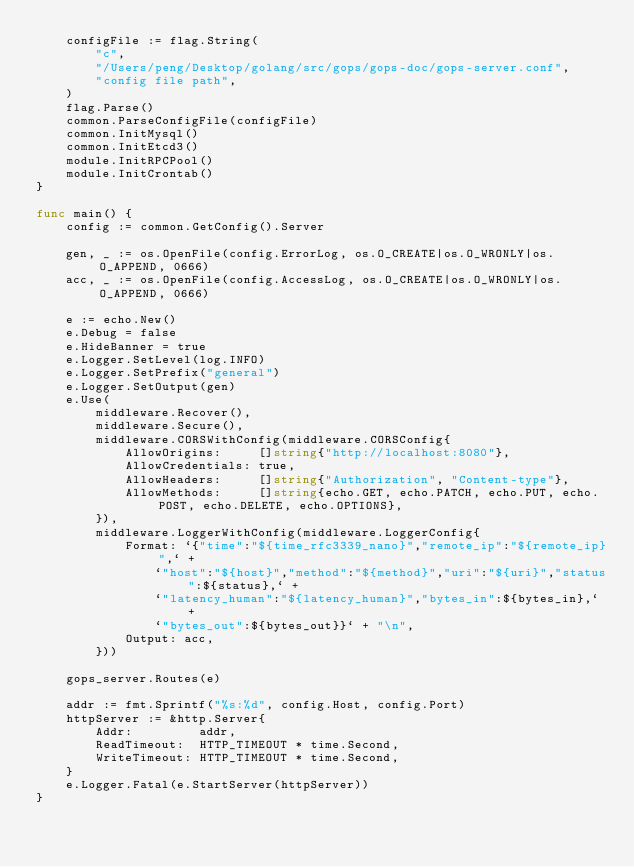<code> <loc_0><loc_0><loc_500><loc_500><_Go_>	configFile := flag.String(
		"c",
		"/Users/peng/Desktop/golang/src/gops/gops-doc/gops-server.conf",
		"config file path",
	)
	flag.Parse()
	common.ParseConfigFile(configFile)
	common.InitMysql()
	common.InitEtcd3()
	module.InitRPCPool()
	module.InitCrontab()
}

func main() {
	config := common.GetConfig().Server

	gen, _ := os.OpenFile(config.ErrorLog, os.O_CREATE|os.O_WRONLY|os.O_APPEND, 0666)
	acc, _ := os.OpenFile(config.AccessLog, os.O_CREATE|os.O_WRONLY|os.O_APPEND, 0666)

	e := echo.New()
	e.Debug = false
	e.HideBanner = true
	e.Logger.SetLevel(log.INFO)
	e.Logger.SetPrefix("general")
	e.Logger.SetOutput(gen)
	e.Use(
		middleware.Recover(),
		middleware.Secure(),
		middleware.CORSWithConfig(middleware.CORSConfig{
			AllowOrigins:     []string{"http://localhost:8080"},
			AllowCredentials: true,
			AllowHeaders:     []string{"Authorization", "Content-type"},
			AllowMethods:     []string{echo.GET, echo.PATCH, echo.PUT, echo.POST, echo.DELETE, echo.OPTIONS},
		}),
		middleware.LoggerWithConfig(middleware.LoggerConfig{
			Format: `{"time":"${time_rfc3339_nano}","remote_ip":"${remote_ip}",` +
				`"host":"${host}","method":"${method}","uri":"${uri}","status":${status},` +
				`"latency_human":"${latency_human}","bytes_in":${bytes_in},` +
				`"bytes_out":${bytes_out}}` + "\n",
			Output: acc,
		}))

	gops_server.Routes(e)

	addr := fmt.Sprintf("%s:%d", config.Host, config.Port)
	httpServer := &http.Server{
		Addr:         addr,
		ReadTimeout:  HTTP_TIMEOUT * time.Second,
		WriteTimeout: HTTP_TIMEOUT * time.Second,
	}
	e.Logger.Fatal(e.StartServer(httpServer))
}
</code> 